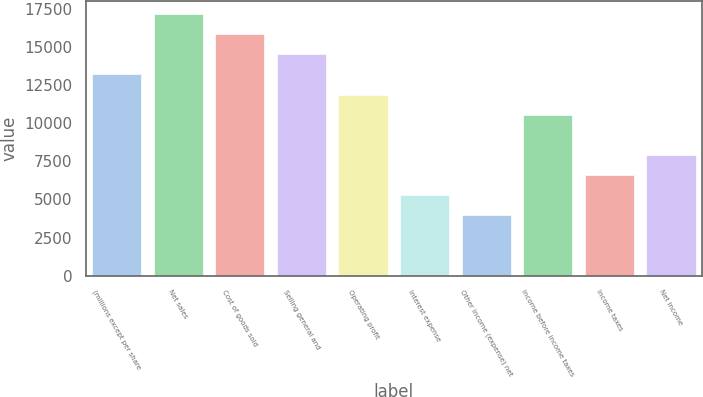Convert chart to OTSL. <chart><loc_0><loc_0><loc_500><loc_500><bar_chart><fcel>(millions except per share<fcel>Net sales<fcel>Cost of goods sold<fcel>Selling general and<fcel>Operating profit<fcel>Interest expense<fcel>Other income (expense) net<fcel>Income before income taxes<fcel>Income taxes<fcel>Net income<nl><fcel>13198<fcel>17156.9<fcel>15837.2<fcel>14517.6<fcel>11878.3<fcel>5280.19<fcel>3960.56<fcel>10558.7<fcel>6599.82<fcel>7919.45<nl></chart> 